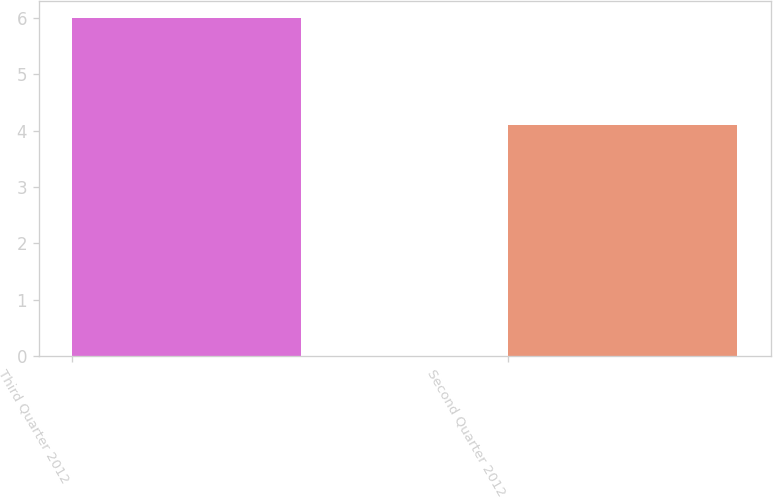<chart> <loc_0><loc_0><loc_500><loc_500><bar_chart><fcel>Third Quarter 2012<fcel>Second Quarter 2012<nl><fcel>6<fcel>4.1<nl></chart> 